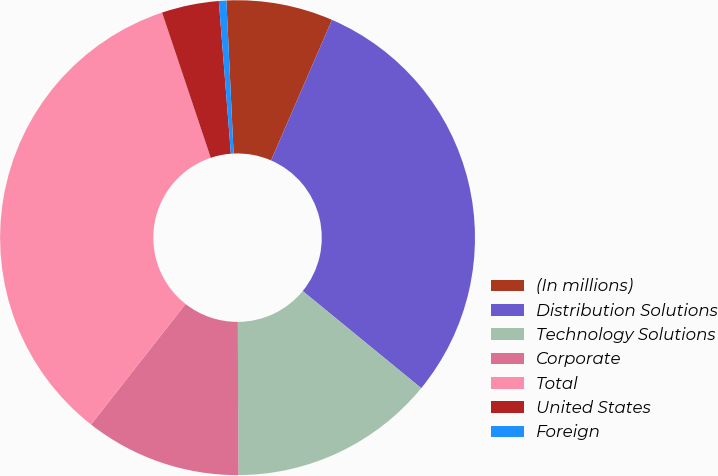Convert chart. <chart><loc_0><loc_0><loc_500><loc_500><pie_chart><fcel>(In millions)<fcel>Distribution Solutions<fcel>Technology Solutions<fcel>Corporate<fcel>Total<fcel>United States<fcel>Foreign<nl><fcel>7.26%<fcel>29.41%<fcel>14.02%<fcel>10.64%<fcel>34.27%<fcel>3.89%<fcel>0.51%<nl></chart> 